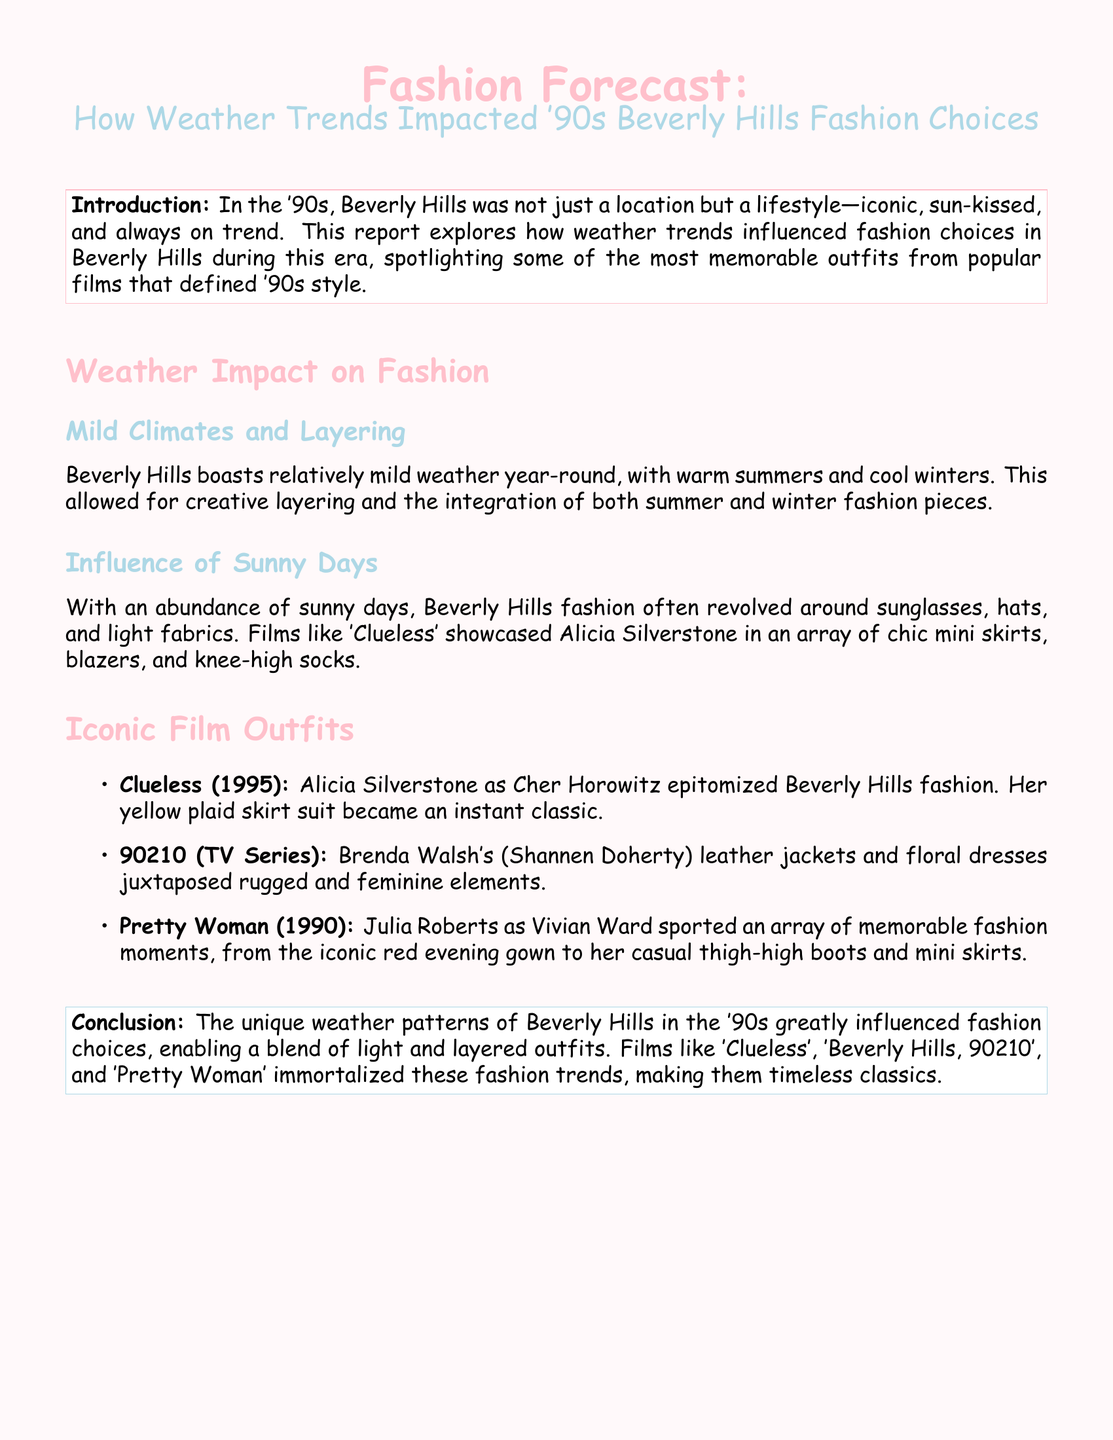What iconic outfit is mentioned from "Clueless"? The document states that Alicia Silverstone's yellow plaid skirt suit became an instant classic.
Answer: yellow plaid skirt suit What weather aspect allowed for creative layering? The document highlights that mild weather year-round in Beverly Hills allowed for creative layering and integration of fashion pieces.
Answer: mild weather Which film features Julia Roberts as Vivian Ward? The document mentions "Pretty Woman" in relation to Julia Roberts' character and her memorable outfits.
Answer: Pretty Woman What kind of fabrics were prevalent due to sunny days? Sunny days in Beverly Hills led to a focus on light fabrics as indicated in the document.
Answer: light fabrics Who played Brenda Walsh in "90210"? The document specifies that Shannen Doherty portrayed Brenda Walsh in the TV series "90210".
Answer: Shannen Doherty What two elements are juxtaposed in Brenda Walsh's fashion? The document notes that Brenda Walsh's fashion includes rugged and feminine elements, creating a contrast.
Answer: rugged and feminine How did the weather impact the iconic style in the '90s? The unique weather patterns allowed for a blend of light and layered outfits as mentioned in the conclusion.
Answer: blend of light and layered outfits What color are the section titles in the document? The section titles are formatted in pink, as the document indicates.
Answer: pink Which TV series is highlighted alongside "Clueless" and "Pretty Woman"? The document highlights "90210" as a significant pop culture reference in relation to '90s fashion.
Answer: 90210 